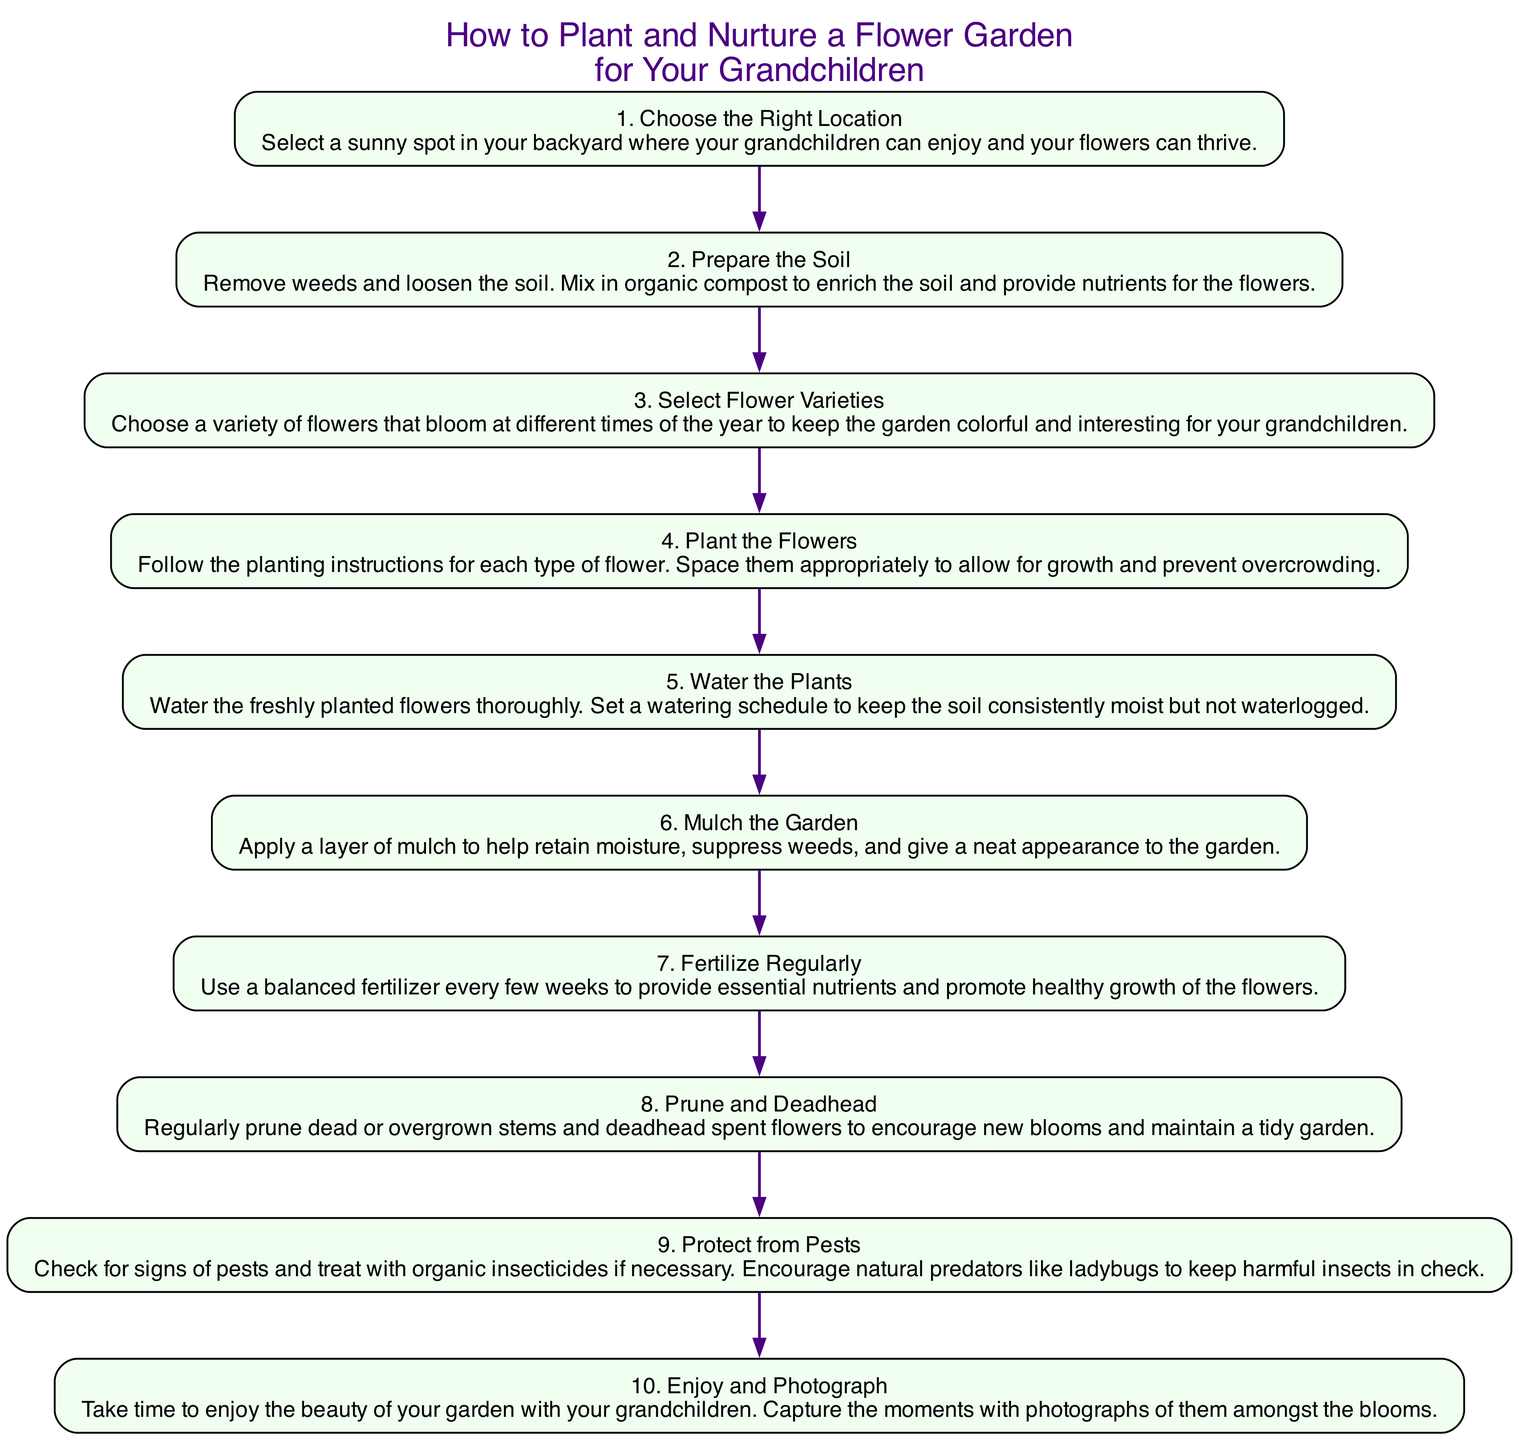What is the first step in planting a flower garden? The first step is "Choose the Right Location," as it is the initial action required to start the gardening process.
Answer: Choose the Right Location How many steps are there in total? The diagram lists ten steps, each representing a distinct action in the process of planting and nurturing a flower garden.
Answer: 10 Which step involves enriching the soil? Step 2, titled "Prepare the Soil," focuses on removing weeds and mixing in organic compost to enrich the soil.
Answer: Prepare the Soil What is the last step in the diagram? The last step is "Enjoy and Photograph," which emphasizes the importance of enjoying the garden with your grandchildren.
Answer: Enjoy and Photograph Which step comes after watering the plants? After "Water the Plants," the next step is "Mulch the Garden," as it directly follows in the sequence of actions.
Answer: Mulch the Garden What is the main action described in step 8? Step 8 describes the action of "Prune and Deadhead," which includes regular maintenance tasks to promote healthy blooms.
Answer: Prune and Deadhead How many steps require the use of a regular schedule? Steps 5 and 7 both require setting a schedule, one for watering and the other for fertilizing, indicating regular attention to the garden.
Answer: 2 Which steps involve dealing with pests? Step 9 specifically addresses protecting from pests, detailing actions to check for and treat infestations as needed.
Answer: Protect from Pests What type of flowers should be selected according to step 3? Step 3 advises selecting a variety of flowers that bloom at different times of the year, enhancing the garden's color throughout the seasons.
Answer: Variety of flowers that bloom at different times What beneficial insects are encouraged in the garden according to step 9? Step 9 mentions encouraging natural predators like ladybugs to help keep harmful insects under control.
Answer: Ladybugs 